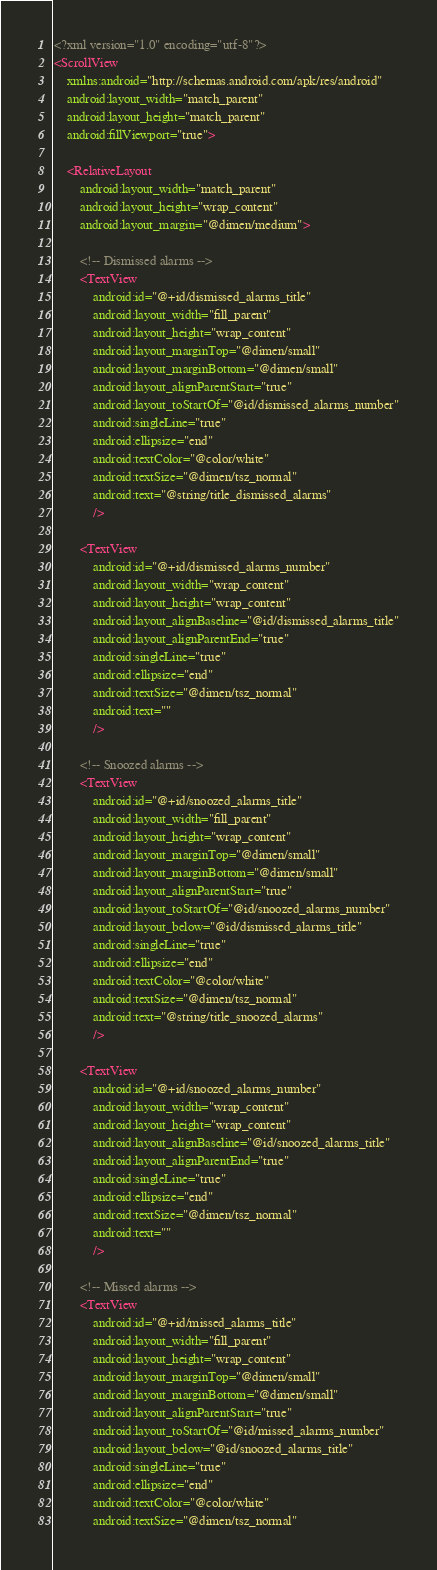<code> <loc_0><loc_0><loc_500><loc_500><_XML_><?xml version="1.0" encoding="utf-8"?>
<ScrollView
	xmlns:android="http://schemas.android.com/apk/res/android"
	android:layout_width="match_parent"
	android:layout_height="match_parent"
	android:fillViewport="true">

	<RelativeLayout
		android:layout_width="match_parent"
		android:layout_height="wrap_content"
		android:layout_margin="@dimen/medium">

		<!-- Dismissed alarms -->
		<TextView
			android:id="@+id/dismissed_alarms_title"
			android:layout_width="fill_parent"
			android:layout_height="wrap_content"
			android:layout_marginTop="@dimen/small"
			android:layout_marginBottom="@dimen/small"
			android:layout_alignParentStart="true"
			android:layout_toStartOf="@id/dismissed_alarms_number"
			android:singleLine="true"
			android:ellipsize="end"
			android:textColor="@color/white"
			android:textSize="@dimen/tsz_normal"
			android:text="@string/title_dismissed_alarms"
			/>

		<TextView
			android:id="@+id/dismissed_alarms_number"
			android:layout_width="wrap_content"
			android:layout_height="wrap_content"
			android:layout_alignBaseline="@id/dismissed_alarms_title"
			android:layout_alignParentEnd="true"
			android:singleLine="true"
			android:ellipsize="end"
			android:textSize="@dimen/tsz_normal"
			android:text=""
			/>

		<!-- Snoozed alarms -->
		<TextView
			android:id="@+id/snoozed_alarms_title"
			android:layout_width="fill_parent"
			android:layout_height="wrap_content"
			android:layout_marginTop="@dimen/small"
			android:layout_marginBottom="@dimen/small"
			android:layout_alignParentStart="true"
			android:layout_toStartOf="@id/snoozed_alarms_number"
			android:layout_below="@id/dismissed_alarms_title"
			android:singleLine="true"
			android:ellipsize="end"
			android:textColor="@color/white"
			android:textSize="@dimen/tsz_normal"
			android:text="@string/title_snoozed_alarms"
			/>

		<TextView
			android:id="@+id/snoozed_alarms_number"
			android:layout_width="wrap_content"
			android:layout_height="wrap_content"
			android:layout_alignBaseline="@id/snoozed_alarms_title"
			android:layout_alignParentEnd="true"
			android:singleLine="true"
			android:ellipsize="end"
			android:textSize="@dimen/tsz_normal"
			android:text=""
			/>

		<!-- Missed alarms -->
		<TextView
			android:id="@+id/missed_alarms_title"
			android:layout_width="fill_parent"
			android:layout_height="wrap_content"
			android:layout_marginTop="@dimen/small"
			android:layout_marginBottom="@dimen/small"
			android:layout_alignParentStart="true"
			android:layout_toStartOf="@id/missed_alarms_number"
			android:layout_below="@id/snoozed_alarms_title"
			android:singleLine="true"
			android:ellipsize="end"
			android:textColor="@color/white"
			android:textSize="@dimen/tsz_normal"</code> 